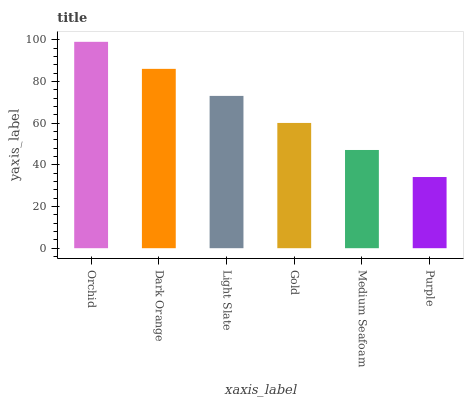Is Purple the minimum?
Answer yes or no. Yes. Is Orchid the maximum?
Answer yes or no. Yes. Is Dark Orange the minimum?
Answer yes or no. No. Is Dark Orange the maximum?
Answer yes or no. No. Is Orchid greater than Dark Orange?
Answer yes or no. Yes. Is Dark Orange less than Orchid?
Answer yes or no. Yes. Is Dark Orange greater than Orchid?
Answer yes or no. No. Is Orchid less than Dark Orange?
Answer yes or no. No. Is Light Slate the high median?
Answer yes or no. Yes. Is Gold the low median?
Answer yes or no. Yes. Is Gold the high median?
Answer yes or no. No. Is Medium Seafoam the low median?
Answer yes or no. No. 